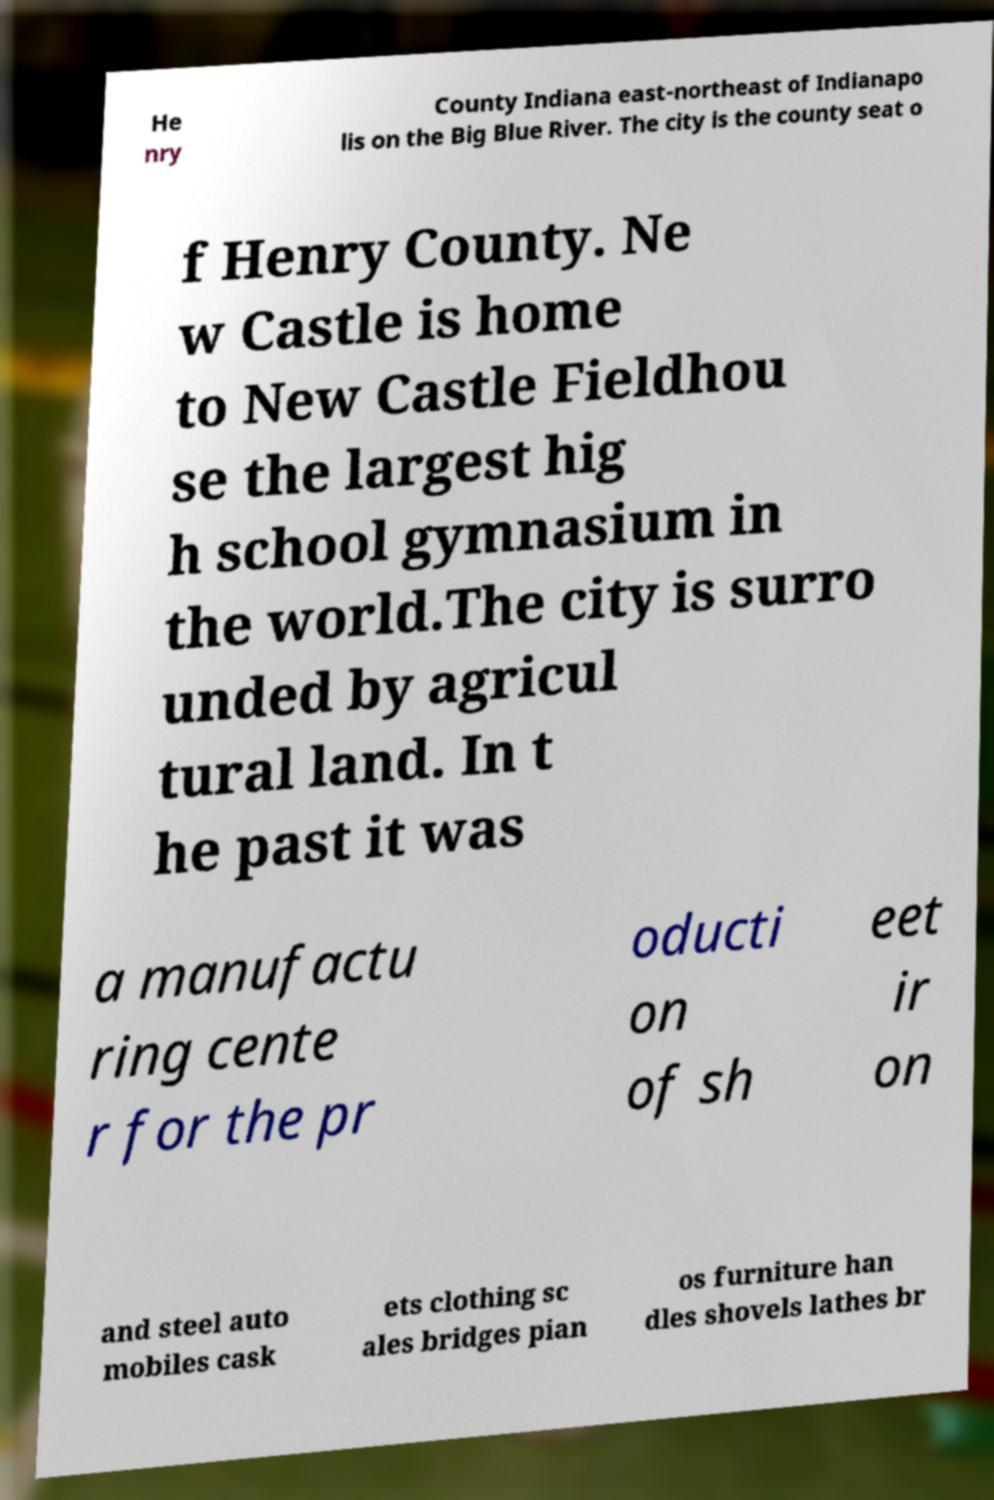Can you read and provide the text displayed in the image?This photo seems to have some interesting text. Can you extract and type it out for me? He nry County Indiana east-northeast of Indianapo lis on the Big Blue River. The city is the county seat o f Henry County. Ne w Castle is home to New Castle Fieldhou se the largest hig h school gymnasium in the world.The city is surro unded by agricul tural land. In t he past it was a manufactu ring cente r for the pr oducti on of sh eet ir on and steel auto mobiles cask ets clothing sc ales bridges pian os furniture han dles shovels lathes br 